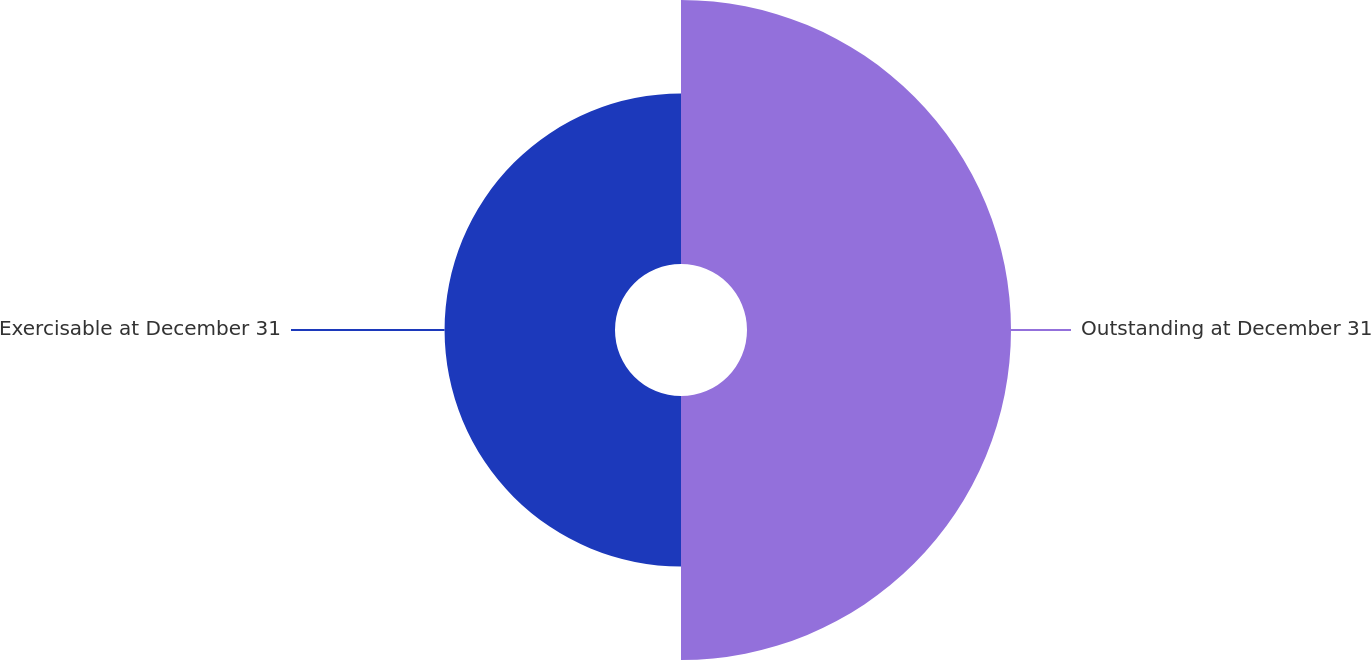<chart> <loc_0><loc_0><loc_500><loc_500><pie_chart><fcel>Outstanding at December 31<fcel>Exercisable at December 31<nl><fcel>60.77%<fcel>39.23%<nl></chart> 